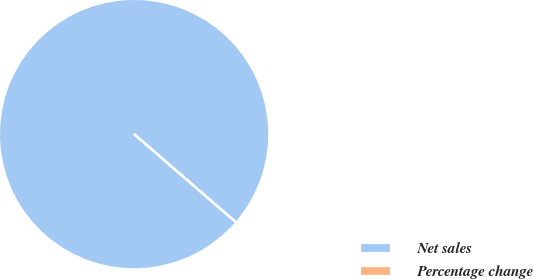Convert chart to OTSL. <chart><loc_0><loc_0><loc_500><loc_500><pie_chart><fcel>Net sales<fcel>Percentage change<nl><fcel>100.0%<fcel>0.0%<nl></chart> 